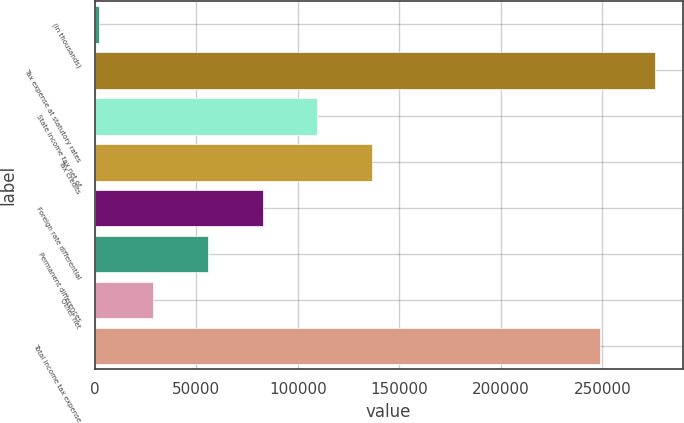<chart> <loc_0><loc_0><loc_500><loc_500><bar_chart><fcel>(In thousands)<fcel>Tax expense at statutory rates<fcel>State income tax net of<fcel>Tax credits<fcel>Foreign rate differential<fcel>Permanent differences<fcel>Other net<fcel>Total income tax expense<nl><fcel>2014<fcel>275636<fcel>109593<fcel>136488<fcel>82698.1<fcel>55803.4<fcel>28908.7<fcel>248741<nl></chart> 